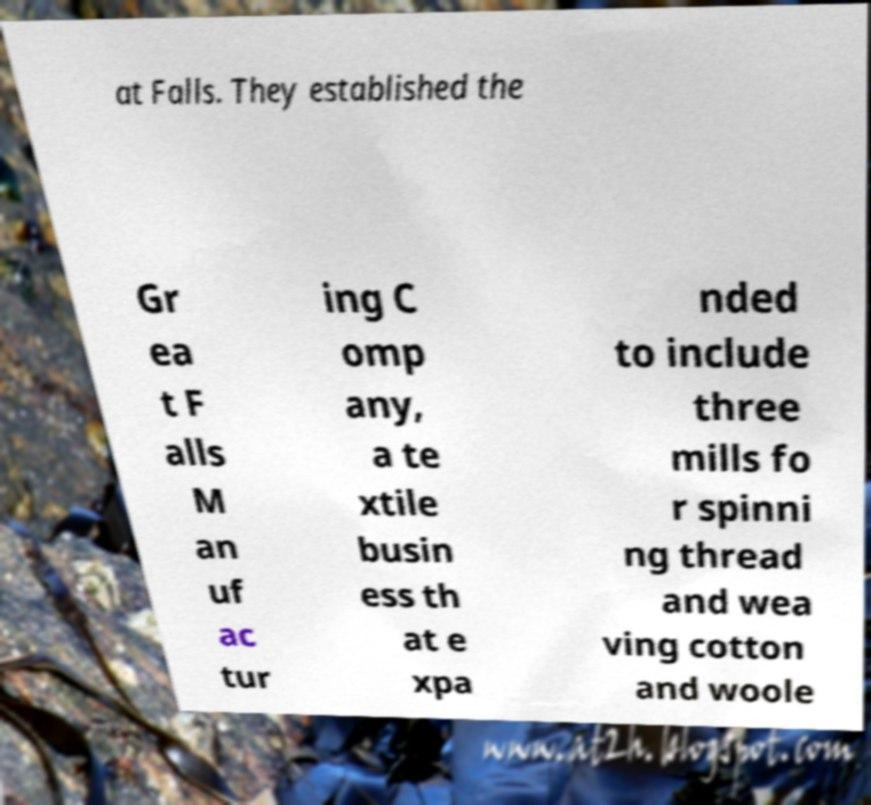What messages or text are displayed in this image? I need them in a readable, typed format. at Falls. They established the Gr ea t F alls M an uf ac tur ing C omp any, a te xtile busin ess th at e xpa nded to include three mills fo r spinni ng thread and wea ving cotton and woole 